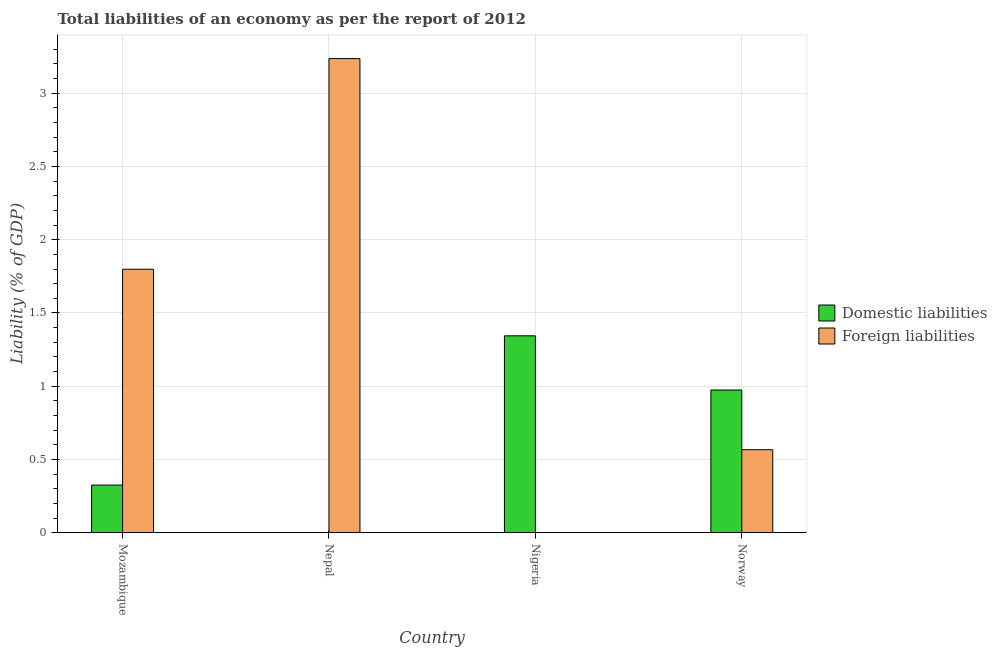How many different coloured bars are there?
Your answer should be very brief. 2. How many bars are there on the 4th tick from the left?
Make the answer very short. 2. How many bars are there on the 4th tick from the right?
Keep it short and to the point. 2. What is the label of the 4th group of bars from the left?
Give a very brief answer. Norway. In how many cases, is the number of bars for a given country not equal to the number of legend labels?
Ensure brevity in your answer.  2. What is the incurrence of domestic liabilities in Nepal?
Ensure brevity in your answer.  0. Across all countries, what is the maximum incurrence of domestic liabilities?
Your response must be concise. 1.34. Across all countries, what is the minimum incurrence of foreign liabilities?
Give a very brief answer. 0. In which country was the incurrence of domestic liabilities maximum?
Make the answer very short. Nigeria. What is the total incurrence of domestic liabilities in the graph?
Your answer should be compact. 2.64. What is the difference between the incurrence of domestic liabilities in Mozambique and that in Norway?
Your response must be concise. -0.65. What is the difference between the incurrence of domestic liabilities in Nepal and the incurrence of foreign liabilities in Nigeria?
Your answer should be compact. 0. What is the average incurrence of foreign liabilities per country?
Give a very brief answer. 1.4. What is the difference between the incurrence of foreign liabilities and incurrence of domestic liabilities in Norway?
Offer a terse response. -0.41. What is the ratio of the incurrence of domestic liabilities in Mozambique to that in Nigeria?
Keep it short and to the point. 0.24. Is the incurrence of domestic liabilities in Nigeria less than that in Norway?
Ensure brevity in your answer.  No. What is the difference between the highest and the second highest incurrence of domestic liabilities?
Provide a succinct answer. 0.37. What is the difference between the highest and the lowest incurrence of domestic liabilities?
Provide a succinct answer. 1.34. In how many countries, is the incurrence of foreign liabilities greater than the average incurrence of foreign liabilities taken over all countries?
Give a very brief answer. 2. Is the sum of the incurrence of domestic liabilities in Mozambique and Nigeria greater than the maximum incurrence of foreign liabilities across all countries?
Provide a short and direct response. No. How many countries are there in the graph?
Your response must be concise. 4. What is the difference between two consecutive major ticks on the Y-axis?
Your answer should be very brief. 0.5. Are the values on the major ticks of Y-axis written in scientific E-notation?
Your response must be concise. No. How many legend labels are there?
Ensure brevity in your answer.  2. What is the title of the graph?
Provide a short and direct response. Total liabilities of an economy as per the report of 2012. Does "Food and tobacco" appear as one of the legend labels in the graph?
Provide a succinct answer. No. What is the label or title of the Y-axis?
Ensure brevity in your answer.  Liability (% of GDP). What is the Liability (% of GDP) in Domestic liabilities in Mozambique?
Give a very brief answer. 0.33. What is the Liability (% of GDP) of Foreign liabilities in Mozambique?
Provide a short and direct response. 1.8. What is the Liability (% of GDP) in Domestic liabilities in Nepal?
Keep it short and to the point. 0. What is the Liability (% of GDP) in Foreign liabilities in Nepal?
Provide a short and direct response. 3.24. What is the Liability (% of GDP) in Domestic liabilities in Nigeria?
Give a very brief answer. 1.34. What is the Liability (% of GDP) of Domestic liabilities in Norway?
Offer a terse response. 0.97. What is the Liability (% of GDP) of Foreign liabilities in Norway?
Offer a very short reply. 0.57. Across all countries, what is the maximum Liability (% of GDP) in Domestic liabilities?
Offer a terse response. 1.34. Across all countries, what is the maximum Liability (% of GDP) in Foreign liabilities?
Give a very brief answer. 3.24. Across all countries, what is the minimum Liability (% of GDP) of Foreign liabilities?
Give a very brief answer. 0. What is the total Liability (% of GDP) of Domestic liabilities in the graph?
Provide a short and direct response. 2.64. What is the total Liability (% of GDP) in Foreign liabilities in the graph?
Your answer should be compact. 5.6. What is the difference between the Liability (% of GDP) in Foreign liabilities in Mozambique and that in Nepal?
Your response must be concise. -1.44. What is the difference between the Liability (% of GDP) in Domestic liabilities in Mozambique and that in Nigeria?
Your response must be concise. -1.02. What is the difference between the Liability (% of GDP) of Domestic liabilities in Mozambique and that in Norway?
Make the answer very short. -0.65. What is the difference between the Liability (% of GDP) of Foreign liabilities in Mozambique and that in Norway?
Your answer should be compact. 1.23. What is the difference between the Liability (% of GDP) of Foreign liabilities in Nepal and that in Norway?
Provide a succinct answer. 2.67. What is the difference between the Liability (% of GDP) in Domestic liabilities in Nigeria and that in Norway?
Offer a very short reply. 0.37. What is the difference between the Liability (% of GDP) in Domestic liabilities in Mozambique and the Liability (% of GDP) in Foreign liabilities in Nepal?
Provide a short and direct response. -2.91. What is the difference between the Liability (% of GDP) in Domestic liabilities in Mozambique and the Liability (% of GDP) in Foreign liabilities in Norway?
Offer a very short reply. -0.24. What is the difference between the Liability (% of GDP) of Domestic liabilities in Nigeria and the Liability (% of GDP) of Foreign liabilities in Norway?
Ensure brevity in your answer.  0.78. What is the average Liability (% of GDP) of Domestic liabilities per country?
Offer a very short reply. 0.66. What is the average Liability (% of GDP) in Foreign liabilities per country?
Keep it short and to the point. 1.4. What is the difference between the Liability (% of GDP) of Domestic liabilities and Liability (% of GDP) of Foreign liabilities in Mozambique?
Make the answer very short. -1.47. What is the difference between the Liability (% of GDP) in Domestic liabilities and Liability (% of GDP) in Foreign liabilities in Norway?
Provide a short and direct response. 0.41. What is the ratio of the Liability (% of GDP) in Foreign liabilities in Mozambique to that in Nepal?
Your response must be concise. 0.56. What is the ratio of the Liability (% of GDP) in Domestic liabilities in Mozambique to that in Nigeria?
Offer a very short reply. 0.24. What is the ratio of the Liability (% of GDP) in Domestic liabilities in Mozambique to that in Norway?
Keep it short and to the point. 0.33. What is the ratio of the Liability (% of GDP) of Foreign liabilities in Mozambique to that in Norway?
Your response must be concise. 3.17. What is the ratio of the Liability (% of GDP) of Foreign liabilities in Nepal to that in Norway?
Offer a terse response. 5.71. What is the ratio of the Liability (% of GDP) of Domestic liabilities in Nigeria to that in Norway?
Offer a terse response. 1.38. What is the difference between the highest and the second highest Liability (% of GDP) in Domestic liabilities?
Make the answer very short. 0.37. What is the difference between the highest and the second highest Liability (% of GDP) in Foreign liabilities?
Offer a very short reply. 1.44. What is the difference between the highest and the lowest Liability (% of GDP) of Domestic liabilities?
Keep it short and to the point. 1.34. What is the difference between the highest and the lowest Liability (% of GDP) in Foreign liabilities?
Offer a terse response. 3.24. 